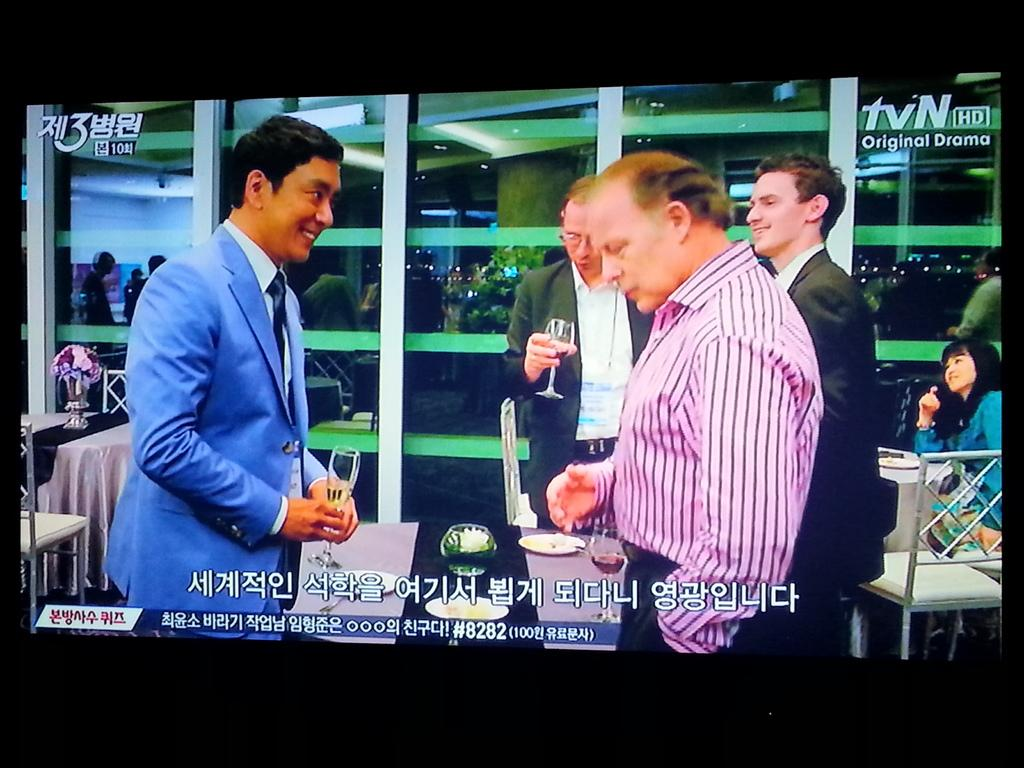What is being displayed on the screen in the image? There is a screen displaying people standing in the image. What are the two people holding in their hands? The two people are holding wine glasses in the image. What type of furniture can be seen in the image? There are tables and chairs in the image. What type of story are the kittens reading in the image? There are no kittens or any reading material present in the image. 